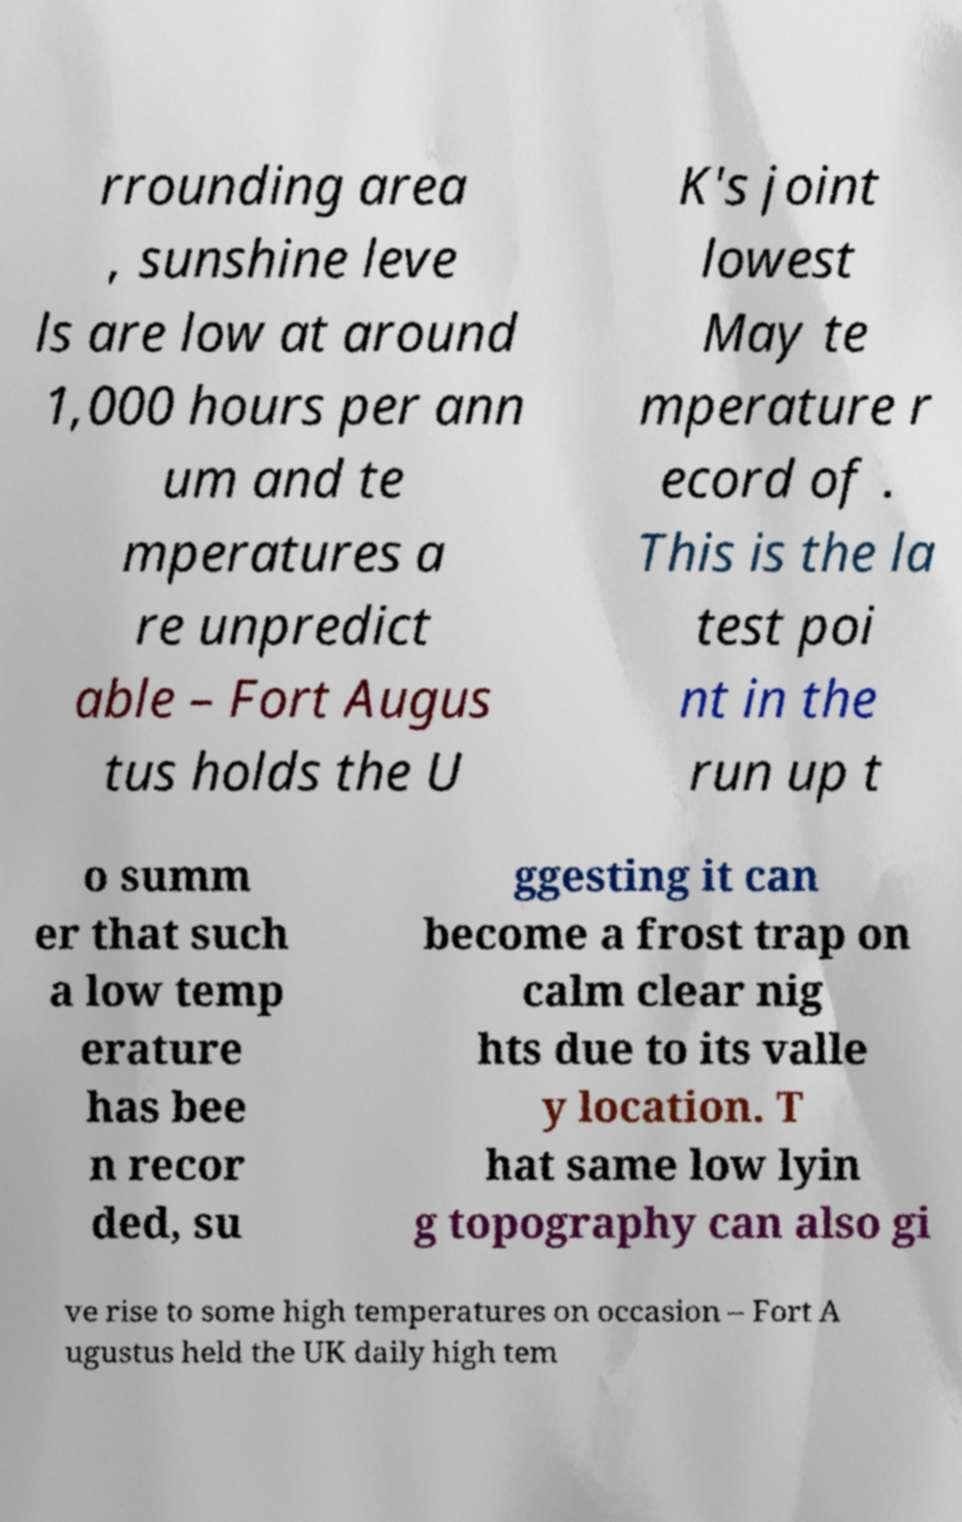Please read and relay the text visible in this image. What does it say? rrounding area , sunshine leve ls are low at around 1,000 hours per ann um and te mperatures a re unpredict able – Fort Augus tus holds the U K's joint lowest May te mperature r ecord of . This is the la test poi nt in the run up t o summ er that such a low temp erature has bee n recor ded, su ggesting it can become a frost trap on calm clear nig hts due to its valle y location. T hat same low lyin g topography can also gi ve rise to some high temperatures on occasion – Fort A ugustus held the UK daily high tem 